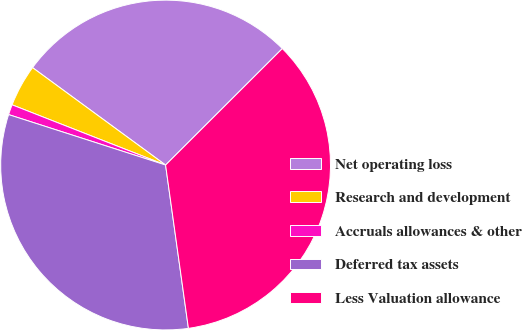Convert chart. <chart><loc_0><loc_0><loc_500><loc_500><pie_chart><fcel>Net operating loss<fcel>Research and development<fcel>Accruals allowances & other<fcel>Deferred tax assets<fcel>Less Valuation allowance<nl><fcel>27.46%<fcel>4.11%<fcel>1.0%<fcel>32.16%<fcel>35.27%<nl></chart> 